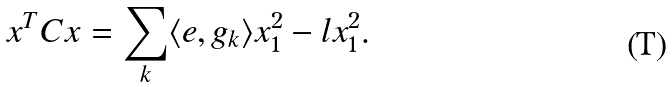<formula> <loc_0><loc_0><loc_500><loc_500>x ^ { T } C x = \sum _ { k } \langle e , g _ { k } \rangle x _ { 1 } ^ { 2 } - l x _ { 1 } ^ { 2 } .</formula> 